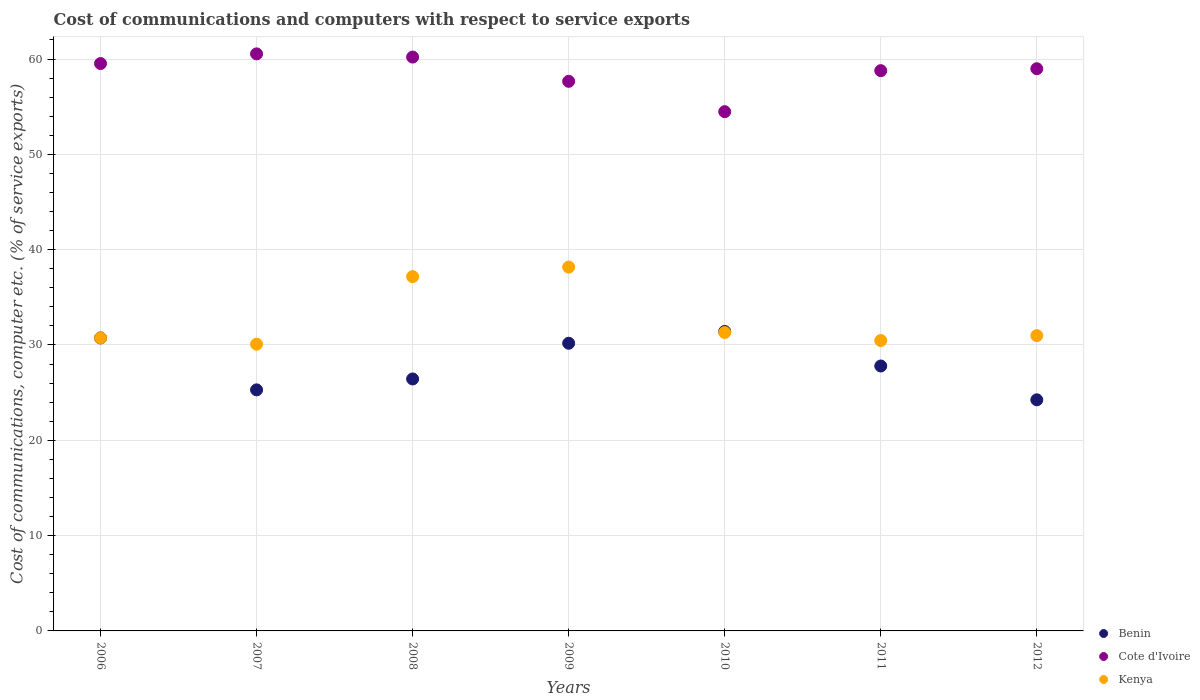Is the number of dotlines equal to the number of legend labels?
Keep it short and to the point. Yes. What is the cost of communications and computers in Benin in 2011?
Your answer should be very brief. 27.8. Across all years, what is the maximum cost of communications and computers in Kenya?
Make the answer very short. 38.17. Across all years, what is the minimum cost of communications and computers in Cote d'Ivoire?
Provide a short and direct response. 54.48. What is the total cost of communications and computers in Benin in the graph?
Your response must be concise. 196.11. What is the difference between the cost of communications and computers in Cote d'Ivoire in 2009 and that in 2010?
Provide a succinct answer. 3.18. What is the difference between the cost of communications and computers in Cote d'Ivoire in 2007 and the cost of communications and computers in Kenya in 2009?
Your response must be concise. 22.37. What is the average cost of communications and computers in Kenya per year?
Ensure brevity in your answer.  32.7. In the year 2006, what is the difference between the cost of communications and computers in Kenya and cost of communications and computers in Cote d'Ivoire?
Give a very brief answer. -28.78. In how many years, is the cost of communications and computers in Cote d'Ivoire greater than 2 %?
Make the answer very short. 7. What is the ratio of the cost of communications and computers in Cote d'Ivoire in 2007 to that in 2012?
Ensure brevity in your answer.  1.03. What is the difference between the highest and the second highest cost of communications and computers in Kenya?
Provide a succinct answer. 1. What is the difference between the highest and the lowest cost of communications and computers in Kenya?
Ensure brevity in your answer.  8.09. In how many years, is the cost of communications and computers in Kenya greater than the average cost of communications and computers in Kenya taken over all years?
Ensure brevity in your answer.  2. Is the cost of communications and computers in Benin strictly less than the cost of communications and computers in Kenya over the years?
Make the answer very short. No. What is the difference between two consecutive major ticks on the Y-axis?
Provide a succinct answer. 10. Are the values on the major ticks of Y-axis written in scientific E-notation?
Offer a terse response. No. Does the graph contain any zero values?
Your answer should be very brief. No. Does the graph contain grids?
Provide a succinct answer. Yes. Where does the legend appear in the graph?
Ensure brevity in your answer.  Bottom right. How are the legend labels stacked?
Keep it short and to the point. Vertical. What is the title of the graph?
Offer a very short reply. Cost of communications and computers with respect to service exports. What is the label or title of the X-axis?
Ensure brevity in your answer.  Years. What is the label or title of the Y-axis?
Provide a succinct answer. Cost of communications, computer etc. (% of service exports). What is the Cost of communications, computer etc. (% of service exports) of Benin in 2006?
Your answer should be very brief. 30.74. What is the Cost of communications, computer etc. (% of service exports) in Cote d'Ivoire in 2006?
Provide a short and direct response. 59.53. What is the Cost of communications, computer etc. (% of service exports) in Kenya in 2006?
Your answer should be compact. 30.74. What is the Cost of communications, computer etc. (% of service exports) of Benin in 2007?
Ensure brevity in your answer.  25.29. What is the Cost of communications, computer etc. (% of service exports) of Cote d'Ivoire in 2007?
Your answer should be very brief. 60.54. What is the Cost of communications, computer etc. (% of service exports) of Kenya in 2007?
Keep it short and to the point. 30.09. What is the Cost of communications, computer etc. (% of service exports) in Benin in 2008?
Your response must be concise. 26.43. What is the Cost of communications, computer etc. (% of service exports) of Cote d'Ivoire in 2008?
Offer a terse response. 60.21. What is the Cost of communications, computer etc. (% of service exports) in Kenya in 2008?
Give a very brief answer. 37.17. What is the Cost of communications, computer etc. (% of service exports) in Benin in 2009?
Give a very brief answer. 30.18. What is the Cost of communications, computer etc. (% of service exports) in Cote d'Ivoire in 2009?
Offer a very short reply. 57.66. What is the Cost of communications, computer etc. (% of service exports) of Kenya in 2009?
Ensure brevity in your answer.  38.17. What is the Cost of communications, computer etc. (% of service exports) of Benin in 2010?
Keep it short and to the point. 31.42. What is the Cost of communications, computer etc. (% of service exports) in Cote d'Ivoire in 2010?
Give a very brief answer. 54.48. What is the Cost of communications, computer etc. (% of service exports) in Kenya in 2010?
Provide a succinct answer. 31.31. What is the Cost of communications, computer etc. (% of service exports) in Benin in 2011?
Provide a succinct answer. 27.8. What is the Cost of communications, computer etc. (% of service exports) of Cote d'Ivoire in 2011?
Your answer should be compact. 58.78. What is the Cost of communications, computer etc. (% of service exports) of Kenya in 2011?
Ensure brevity in your answer.  30.47. What is the Cost of communications, computer etc. (% of service exports) of Benin in 2012?
Your answer should be compact. 24.25. What is the Cost of communications, computer etc. (% of service exports) in Cote d'Ivoire in 2012?
Make the answer very short. 58.99. What is the Cost of communications, computer etc. (% of service exports) in Kenya in 2012?
Your answer should be compact. 30.98. Across all years, what is the maximum Cost of communications, computer etc. (% of service exports) in Benin?
Ensure brevity in your answer.  31.42. Across all years, what is the maximum Cost of communications, computer etc. (% of service exports) in Cote d'Ivoire?
Give a very brief answer. 60.54. Across all years, what is the maximum Cost of communications, computer etc. (% of service exports) in Kenya?
Ensure brevity in your answer.  38.17. Across all years, what is the minimum Cost of communications, computer etc. (% of service exports) of Benin?
Provide a succinct answer. 24.25. Across all years, what is the minimum Cost of communications, computer etc. (% of service exports) in Cote d'Ivoire?
Keep it short and to the point. 54.48. Across all years, what is the minimum Cost of communications, computer etc. (% of service exports) in Kenya?
Offer a terse response. 30.09. What is the total Cost of communications, computer etc. (% of service exports) in Benin in the graph?
Make the answer very short. 196.11. What is the total Cost of communications, computer etc. (% of service exports) in Cote d'Ivoire in the graph?
Make the answer very short. 410.19. What is the total Cost of communications, computer etc. (% of service exports) in Kenya in the graph?
Provide a succinct answer. 228.93. What is the difference between the Cost of communications, computer etc. (% of service exports) of Benin in 2006 and that in 2007?
Your answer should be compact. 5.45. What is the difference between the Cost of communications, computer etc. (% of service exports) in Cote d'Ivoire in 2006 and that in 2007?
Your answer should be very brief. -1.02. What is the difference between the Cost of communications, computer etc. (% of service exports) of Kenya in 2006 and that in 2007?
Your response must be concise. 0.66. What is the difference between the Cost of communications, computer etc. (% of service exports) of Benin in 2006 and that in 2008?
Keep it short and to the point. 4.3. What is the difference between the Cost of communications, computer etc. (% of service exports) of Cote d'Ivoire in 2006 and that in 2008?
Give a very brief answer. -0.68. What is the difference between the Cost of communications, computer etc. (% of service exports) in Kenya in 2006 and that in 2008?
Make the answer very short. -6.43. What is the difference between the Cost of communications, computer etc. (% of service exports) in Benin in 2006 and that in 2009?
Give a very brief answer. 0.56. What is the difference between the Cost of communications, computer etc. (% of service exports) in Cote d'Ivoire in 2006 and that in 2009?
Your answer should be compact. 1.86. What is the difference between the Cost of communications, computer etc. (% of service exports) in Kenya in 2006 and that in 2009?
Your answer should be compact. -7.43. What is the difference between the Cost of communications, computer etc. (% of service exports) in Benin in 2006 and that in 2010?
Keep it short and to the point. -0.68. What is the difference between the Cost of communications, computer etc. (% of service exports) of Cote d'Ivoire in 2006 and that in 2010?
Your answer should be compact. 5.05. What is the difference between the Cost of communications, computer etc. (% of service exports) in Kenya in 2006 and that in 2010?
Give a very brief answer. -0.56. What is the difference between the Cost of communications, computer etc. (% of service exports) in Benin in 2006 and that in 2011?
Your answer should be compact. 2.94. What is the difference between the Cost of communications, computer etc. (% of service exports) of Cote d'Ivoire in 2006 and that in 2011?
Make the answer very short. 0.75. What is the difference between the Cost of communications, computer etc. (% of service exports) of Kenya in 2006 and that in 2011?
Your answer should be very brief. 0.28. What is the difference between the Cost of communications, computer etc. (% of service exports) of Benin in 2006 and that in 2012?
Give a very brief answer. 6.49. What is the difference between the Cost of communications, computer etc. (% of service exports) of Cote d'Ivoire in 2006 and that in 2012?
Keep it short and to the point. 0.54. What is the difference between the Cost of communications, computer etc. (% of service exports) of Kenya in 2006 and that in 2012?
Keep it short and to the point. -0.24. What is the difference between the Cost of communications, computer etc. (% of service exports) in Benin in 2007 and that in 2008?
Provide a succinct answer. -1.14. What is the difference between the Cost of communications, computer etc. (% of service exports) of Cote d'Ivoire in 2007 and that in 2008?
Your answer should be compact. 0.34. What is the difference between the Cost of communications, computer etc. (% of service exports) in Kenya in 2007 and that in 2008?
Provide a succinct answer. -7.08. What is the difference between the Cost of communications, computer etc. (% of service exports) of Benin in 2007 and that in 2009?
Give a very brief answer. -4.89. What is the difference between the Cost of communications, computer etc. (% of service exports) in Cote d'Ivoire in 2007 and that in 2009?
Give a very brief answer. 2.88. What is the difference between the Cost of communications, computer etc. (% of service exports) in Kenya in 2007 and that in 2009?
Offer a very short reply. -8.09. What is the difference between the Cost of communications, computer etc. (% of service exports) of Benin in 2007 and that in 2010?
Your answer should be very brief. -6.13. What is the difference between the Cost of communications, computer etc. (% of service exports) of Cote d'Ivoire in 2007 and that in 2010?
Provide a short and direct response. 6.07. What is the difference between the Cost of communications, computer etc. (% of service exports) in Kenya in 2007 and that in 2010?
Your answer should be very brief. -1.22. What is the difference between the Cost of communications, computer etc. (% of service exports) in Benin in 2007 and that in 2011?
Give a very brief answer. -2.5. What is the difference between the Cost of communications, computer etc. (% of service exports) of Cote d'Ivoire in 2007 and that in 2011?
Give a very brief answer. 1.76. What is the difference between the Cost of communications, computer etc. (% of service exports) of Kenya in 2007 and that in 2011?
Keep it short and to the point. -0.38. What is the difference between the Cost of communications, computer etc. (% of service exports) of Benin in 2007 and that in 2012?
Offer a very short reply. 1.04. What is the difference between the Cost of communications, computer etc. (% of service exports) in Cote d'Ivoire in 2007 and that in 2012?
Make the answer very short. 1.56. What is the difference between the Cost of communications, computer etc. (% of service exports) in Kenya in 2007 and that in 2012?
Offer a terse response. -0.9. What is the difference between the Cost of communications, computer etc. (% of service exports) of Benin in 2008 and that in 2009?
Your answer should be compact. -3.75. What is the difference between the Cost of communications, computer etc. (% of service exports) in Cote d'Ivoire in 2008 and that in 2009?
Offer a terse response. 2.54. What is the difference between the Cost of communications, computer etc. (% of service exports) in Kenya in 2008 and that in 2009?
Keep it short and to the point. -1. What is the difference between the Cost of communications, computer etc. (% of service exports) in Benin in 2008 and that in 2010?
Ensure brevity in your answer.  -4.99. What is the difference between the Cost of communications, computer etc. (% of service exports) of Cote d'Ivoire in 2008 and that in 2010?
Make the answer very short. 5.73. What is the difference between the Cost of communications, computer etc. (% of service exports) in Kenya in 2008 and that in 2010?
Your response must be concise. 5.86. What is the difference between the Cost of communications, computer etc. (% of service exports) in Benin in 2008 and that in 2011?
Provide a succinct answer. -1.36. What is the difference between the Cost of communications, computer etc. (% of service exports) in Cote d'Ivoire in 2008 and that in 2011?
Offer a terse response. 1.43. What is the difference between the Cost of communications, computer etc. (% of service exports) of Kenya in 2008 and that in 2011?
Make the answer very short. 6.7. What is the difference between the Cost of communications, computer etc. (% of service exports) of Benin in 2008 and that in 2012?
Offer a very short reply. 2.19. What is the difference between the Cost of communications, computer etc. (% of service exports) in Cote d'Ivoire in 2008 and that in 2012?
Provide a succinct answer. 1.22. What is the difference between the Cost of communications, computer etc. (% of service exports) of Kenya in 2008 and that in 2012?
Your answer should be very brief. 6.19. What is the difference between the Cost of communications, computer etc. (% of service exports) in Benin in 2009 and that in 2010?
Your answer should be very brief. -1.24. What is the difference between the Cost of communications, computer etc. (% of service exports) in Cote d'Ivoire in 2009 and that in 2010?
Keep it short and to the point. 3.19. What is the difference between the Cost of communications, computer etc. (% of service exports) of Kenya in 2009 and that in 2010?
Make the answer very short. 6.87. What is the difference between the Cost of communications, computer etc. (% of service exports) in Benin in 2009 and that in 2011?
Keep it short and to the point. 2.39. What is the difference between the Cost of communications, computer etc. (% of service exports) of Cote d'Ivoire in 2009 and that in 2011?
Offer a terse response. -1.12. What is the difference between the Cost of communications, computer etc. (% of service exports) in Kenya in 2009 and that in 2011?
Your answer should be compact. 7.71. What is the difference between the Cost of communications, computer etc. (% of service exports) in Benin in 2009 and that in 2012?
Make the answer very short. 5.93. What is the difference between the Cost of communications, computer etc. (% of service exports) of Cote d'Ivoire in 2009 and that in 2012?
Offer a very short reply. -1.32. What is the difference between the Cost of communications, computer etc. (% of service exports) in Kenya in 2009 and that in 2012?
Provide a succinct answer. 7.19. What is the difference between the Cost of communications, computer etc. (% of service exports) in Benin in 2010 and that in 2011?
Provide a succinct answer. 3.63. What is the difference between the Cost of communications, computer etc. (% of service exports) in Cote d'Ivoire in 2010 and that in 2011?
Your answer should be very brief. -4.3. What is the difference between the Cost of communications, computer etc. (% of service exports) in Kenya in 2010 and that in 2011?
Ensure brevity in your answer.  0.84. What is the difference between the Cost of communications, computer etc. (% of service exports) in Benin in 2010 and that in 2012?
Ensure brevity in your answer.  7.17. What is the difference between the Cost of communications, computer etc. (% of service exports) of Cote d'Ivoire in 2010 and that in 2012?
Ensure brevity in your answer.  -4.51. What is the difference between the Cost of communications, computer etc. (% of service exports) of Kenya in 2010 and that in 2012?
Provide a short and direct response. 0.33. What is the difference between the Cost of communications, computer etc. (% of service exports) in Benin in 2011 and that in 2012?
Your answer should be compact. 3.55. What is the difference between the Cost of communications, computer etc. (% of service exports) of Cote d'Ivoire in 2011 and that in 2012?
Provide a short and direct response. -0.2. What is the difference between the Cost of communications, computer etc. (% of service exports) in Kenya in 2011 and that in 2012?
Keep it short and to the point. -0.52. What is the difference between the Cost of communications, computer etc. (% of service exports) of Benin in 2006 and the Cost of communications, computer etc. (% of service exports) of Cote d'Ivoire in 2007?
Offer a very short reply. -29.8. What is the difference between the Cost of communications, computer etc. (% of service exports) of Benin in 2006 and the Cost of communications, computer etc. (% of service exports) of Kenya in 2007?
Provide a short and direct response. 0.65. What is the difference between the Cost of communications, computer etc. (% of service exports) of Cote d'Ivoire in 2006 and the Cost of communications, computer etc. (% of service exports) of Kenya in 2007?
Your answer should be very brief. 29.44. What is the difference between the Cost of communications, computer etc. (% of service exports) in Benin in 2006 and the Cost of communications, computer etc. (% of service exports) in Cote d'Ivoire in 2008?
Ensure brevity in your answer.  -29.47. What is the difference between the Cost of communications, computer etc. (% of service exports) of Benin in 2006 and the Cost of communications, computer etc. (% of service exports) of Kenya in 2008?
Provide a succinct answer. -6.43. What is the difference between the Cost of communications, computer etc. (% of service exports) of Cote d'Ivoire in 2006 and the Cost of communications, computer etc. (% of service exports) of Kenya in 2008?
Provide a succinct answer. 22.36. What is the difference between the Cost of communications, computer etc. (% of service exports) of Benin in 2006 and the Cost of communications, computer etc. (% of service exports) of Cote d'Ivoire in 2009?
Offer a very short reply. -26.92. What is the difference between the Cost of communications, computer etc. (% of service exports) of Benin in 2006 and the Cost of communications, computer etc. (% of service exports) of Kenya in 2009?
Provide a succinct answer. -7.43. What is the difference between the Cost of communications, computer etc. (% of service exports) in Cote d'Ivoire in 2006 and the Cost of communications, computer etc. (% of service exports) in Kenya in 2009?
Provide a succinct answer. 21.35. What is the difference between the Cost of communications, computer etc. (% of service exports) in Benin in 2006 and the Cost of communications, computer etc. (% of service exports) in Cote d'Ivoire in 2010?
Offer a terse response. -23.74. What is the difference between the Cost of communications, computer etc. (% of service exports) in Benin in 2006 and the Cost of communications, computer etc. (% of service exports) in Kenya in 2010?
Offer a very short reply. -0.57. What is the difference between the Cost of communications, computer etc. (% of service exports) of Cote d'Ivoire in 2006 and the Cost of communications, computer etc. (% of service exports) of Kenya in 2010?
Your answer should be very brief. 28.22. What is the difference between the Cost of communications, computer etc. (% of service exports) in Benin in 2006 and the Cost of communications, computer etc. (% of service exports) in Cote d'Ivoire in 2011?
Ensure brevity in your answer.  -28.04. What is the difference between the Cost of communications, computer etc. (% of service exports) of Benin in 2006 and the Cost of communications, computer etc. (% of service exports) of Kenya in 2011?
Offer a very short reply. 0.27. What is the difference between the Cost of communications, computer etc. (% of service exports) of Cote d'Ivoire in 2006 and the Cost of communications, computer etc. (% of service exports) of Kenya in 2011?
Your response must be concise. 29.06. What is the difference between the Cost of communications, computer etc. (% of service exports) in Benin in 2006 and the Cost of communications, computer etc. (% of service exports) in Cote d'Ivoire in 2012?
Offer a terse response. -28.25. What is the difference between the Cost of communications, computer etc. (% of service exports) of Benin in 2006 and the Cost of communications, computer etc. (% of service exports) of Kenya in 2012?
Offer a very short reply. -0.24. What is the difference between the Cost of communications, computer etc. (% of service exports) in Cote d'Ivoire in 2006 and the Cost of communications, computer etc. (% of service exports) in Kenya in 2012?
Give a very brief answer. 28.55. What is the difference between the Cost of communications, computer etc. (% of service exports) of Benin in 2007 and the Cost of communications, computer etc. (% of service exports) of Cote d'Ivoire in 2008?
Offer a very short reply. -34.92. What is the difference between the Cost of communications, computer etc. (% of service exports) in Benin in 2007 and the Cost of communications, computer etc. (% of service exports) in Kenya in 2008?
Offer a very short reply. -11.88. What is the difference between the Cost of communications, computer etc. (% of service exports) of Cote d'Ivoire in 2007 and the Cost of communications, computer etc. (% of service exports) of Kenya in 2008?
Provide a succinct answer. 23.37. What is the difference between the Cost of communications, computer etc. (% of service exports) of Benin in 2007 and the Cost of communications, computer etc. (% of service exports) of Cote d'Ivoire in 2009?
Offer a very short reply. -32.37. What is the difference between the Cost of communications, computer etc. (% of service exports) of Benin in 2007 and the Cost of communications, computer etc. (% of service exports) of Kenya in 2009?
Provide a short and direct response. -12.88. What is the difference between the Cost of communications, computer etc. (% of service exports) in Cote d'Ivoire in 2007 and the Cost of communications, computer etc. (% of service exports) in Kenya in 2009?
Provide a short and direct response. 22.37. What is the difference between the Cost of communications, computer etc. (% of service exports) in Benin in 2007 and the Cost of communications, computer etc. (% of service exports) in Cote d'Ivoire in 2010?
Make the answer very short. -29.19. What is the difference between the Cost of communications, computer etc. (% of service exports) in Benin in 2007 and the Cost of communications, computer etc. (% of service exports) in Kenya in 2010?
Your response must be concise. -6.02. What is the difference between the Cost of communications, computer etc. (% of service exports) in Cote d'Ivoire in 2007 and the Cost of communications, computer etc. (% of service exports) in Kenya in 2010?
Give a very brief answer. 29.24. What is the difference between the Cost of communications, computer etc. (% of service exports) of Benin in 2007 and the Cost of communications, computer etc. (% of service exports) of Cote d'Ivoire in 2011?
Provide a succinct answer. -33.49. What is the difference between the Cost of communications, computer etc. (% of service exports) of Benin in 2007 and the Cost of communications, computer etc. (% of service exports) of Kenya in 2011?
Give a very brief answer. -5.18. What is the difference between the Cost of communications, computer etc. (% of service exports) of Cote d'Ivoire in 2007 and the Cost of communications, computer etc. (% of service exports) of Kenya in 2011?
Provide a succinct answer. 30.08. What is the difference between the Cost of communications, computer etc. (% of service exports) of Benin in 2007 and the Cost of communications, computer etc. (% of service exports) of Cote d'Ivoire in 2012?
Offer a very short reply. -33.7. What is the difference between the Cost of communications, computer etc. (% of service exports) of Benin in 2007 and the Cost of communications, computer etc. (% of service exports) of Kenya in 2012?
Your answer should be compact. -5.69. What is the difference between the Cost of communications, computer etc. (% of service exports) of Cote d'Ivoire in 2007 and the Cost of communications, computer etc. (% of service exports) of Kenya in 2012?
Make the answer very short. 29.56. What is the difference between the Cost of communications, computer etc. (% of service exports) of Benin in 2008 and the Cost of communications, computer etc. (% of service exports) of Cote d'Ivoire in 2009?
Keep it short and to the point. -31.23. What is the difference between the Cost of communications, computer etc. (% of service exports) in Benin in 2008 and the Cost of communications, computer etc. (% of service exports) in Kenya in 2009?
Provide a succinct answer. -11.74. What is the difference between the Cost of communications, computer etc. (% of service exports) of Cote d'Ivoire in 2008 and the Cost of communications, computer etc. (% of service exports) of Kenya in 2009?
Provide a short and direct response. 22.03. What is the difference between the Cost of communications, computer etc. (% of service exports) in Benin in 2008 and the Cost of communications, computer etc. (% of service exports) in Cote d'Ivoire in 2010?
Give a very brief answer. -28.04. What is the difference between the Cost of communications, computer etc. (% of service exports) of Benin in 2008 and the Cost of communications, computer etc. (% of service exports) of Kenya in 2010?
Provide a succinct answer. -4.87. What is the difference between the Cost of communications, computer etc. (% of service exports) in Cote d'Ivoire in 2008 and the Cost of communications, computer etc. (% of service exports) in Kenya in 2010?
Your response must be concise. 28.9. What is the difference between the Cost of communications, computer etc. (% of service exports) of Benin in 2008 and the Cost of communications, computer etc. (% of service exports) of Cote d'Ivoire in 2011?
Your answer should be very brief. -32.35. What is the difference between the Cost of communications, computer etc. (% of service exports) in Benin in 2008 and the Cost of communications, computer etc. (% of service exports) in Kenya in 2011?
Give a very brief answer. -4.03. What is the difference between the Cost of communications, computer etc. (% of service exports) of Cote d'Ivoire in 2008 and the Cost of communications, computer etc. (% of service exports) of Kenya in 2011?
Offer a terse response. 29.74. What is the difference between the Cost of communications, computer etc. (% of service exports) in Benin in 2008 and the Cost of communications, computer etc. (% of service exports) in Cote d'Ivoire in 2012?
Your response must be concise. -32.55. What is the difference between the Cost of communications, computer etc. (% of service exports) in Benin in 2008 and the Cost of communications, computer etc. (% of service exports) in Kenya in 2012?
Keep it short and to the point. -4.55. What is the difference between the Cost of communications, computer etc. (% of service exports) of Cote d'Ivoire in 2008 and the Cost of communications, computer etc. (% of service exports) of Kenya in 2012?
Give a very brief answer. 29.23. What is the difference between the Cost of communications, computer etc. (% of service exports) in Benin in 2009 and the Cost of communications, computer etc. (% of service exports) in Cote d'Ivoire in 2010?
Provide a short and direct response. -24.3. What is the difference between the Cost of communications, computer etc. (% of service exports) of Benin in 2009 and the Cost of communications, computer etc. (% of service exports) of Kenya in 2010?
Provide a succinct answer. -1.13. What is the difference between the Cost of communications, computer etc. (% of service exports) of Cote d'Ivoire in 2009 and the Cost of communications, computer etc. (% of service exports) of Kenya in 2010?
Make the answer very short. 26.36. What is the difference between the Cost of communications, computer etc. (% of service exports) of Benin in 2009 and the Cost of communications, computer etc. (% of service exports) of Cote d'Ivoire in 2011?
Provide a succinct answer. -28.6. What is the difference between the Cost of communications, computer etc. (% of service exports) of Benin in 2009 and the Cost of communications, computer etc. (% of service exports) of Kenya in 2011?
Your answer should be very brief. -0.28. What is the difference between the Cost of communications, computer etc. (% of service exports) in Cote d'Ivoire in 2009 and the Cost of communications, computer etc. (% of service exports) in Kenya in 2011?
Your response must be concise. 27.2. What is the difference between the Cost of communications, computer etc. (% of service exports) in Benin in 2009 and the Cost of communications, computer etc. (% of service exports) in Cote d'Ivoire in 2012?
Give a very brief answer. -28.8. What is the difference between the Cost of communications, computer etc. (% of service exports) of Benin in 2009 and the Cost of communications, computer etc. (% of service exports) of Kenya in 2012?
Your answer should be very brief. -0.8. What is the difference between the Cost of communications, computer etc. (% of service exports) of Cote d'Ivoire in 2009 and the Cost of communications, computer etc. (% of service exports) of Kenya in 2012?
Offer a very short reply. 26.68. What is the difference between the Cost of communications, computer etc. (% of service exports) in Benin in 2010 and the Cost of communications, computer etc. (% of service exports) in Cote d'Ivoire in 2011?
Keep it short and to the point. -27.36. What is the difference between the Cost of communications, computer etc. (% of service exports) of Benin in 2010 and the Cost of communications, computer etc. (% of service exports) of Kenya in 2011?
Ensure brevity in your answer.  0.95. What is the difference between the Cost of communications, computer etc. (% of service exports) of Cote d'Ivoire in 2010 and the Cost of communications, computer etc. (% of service exports) of Kenya in 2011?
Offer a terse response. 24.01. What is the difference between the Cost of communications, computer etc. (% of service exports) in Benin in 2010 and the Cost of communications, computer etc. (% of service exports) in Cote d'Ivoire in 2012?
Ensure brevity in your answer.  -27.57. What is the difference between the Cost of communications, computer etc. (% of service exports) in Benin in 2010 and the Cost of communications, computer etc. (% of service exports) in Kenya in 2012?
Ensure brevity in your answer.  0.44. What is the difference between the Cost of communications, computer etc. (% of service exports) of Cote d'Ivoire in 2010 and the Cost of communications, computer etc. (% of service exports) of Kenya in 2012?
Provide a succinct answer. 23.5. What is the difference between the Cost of communications, computer etc. (% of service exports) in Benin in 2011 and the Cost of communications, computer etc. (% of service exports) in Cote d'Ivoire in 2012?
Your answer should be very brief. -31.19. What is the difference between the Cost of communications, computer etc. (% of service exports) in Benin in 2011 and the Cost of communications, computer etc. (% of service exports) in Kenya in 2012?
Provide a succinct answer. -3.19. What is the difference between the Cost of communications, computer etc. (% of service exports) of Cote d'Ivoire in 2011 and the Cost of communications, computer etc. (% of service exports) of Kenya in 2012?
Your answer should be very brief. 27.8. What is the average Cost of communications, computer etc. (% of service exports) of Benin per year?
Offer a terse response. 28.02. What is the average Cost of communications, computer etc. (% of service exports) of Cote d'Ivoire per year?
Ensure brevity in your answer.  58.6. What is the average Cost of communications, computer etc. (% of service exports) of Kenya per year?
Offer a terse response. 32.7. In the year 2006, what is the difference between the Cost of communications, computer etc. (% of service exports) in Benin and Cost of communications, computer etc. (% of service exports) in Cote d'Ivoire?
Your answer should be very brief. -28.79. In the year 2006, what is the difference between the Cost of communications, computer etc. (% of service exports) in Benin and Cost of communications, computer etc. (% of service exports) in Kenya?
Give a very brief answer. -0. In the year 2006, what is the difference between the Cost of communications, computer etc. (% of service exports) of Cote d'Ivoire and Cost of communications, computer etc. (% of service exports) of Kenya?
Offer a very short reply. 28.78. In the year 2007, what is the difference between the Cost of communications, computer etc. (% of service exports) of Benin and Cost of communications, computer etc. (% of service exports) of Cote d'Ivoire?
Ensure brevity in your answer.  -35.25. In the year 2007, what is the difference between the Cost of communications, computer etc. (% of service exports) of Benin and Cost of communications, computer etc. (% of service exports) of Kenya?
Offer a very short reply. -4.8. In the year 2007, what is the difference between the Cost of communications, computer etc. (% of service exports) of Cote d'Ivoire and Cost of communications, computer etc. (% of service exports) of Kenya?
Ensure brevity in your answer.  30.46. In the year 2008, what is the difference between the Cost of communications, computer etc. (% of service exports) of Benin and Cost of communications, computer etc. (% of service exports) of Cote d'Ivoire?
Make the answer very short. -33.77. In the year 2008, what is the difference between the Cost of communications, computer etc. (% of service exports) of Benin and Cost of communications, computer etc. (% of service exports) of Kenya?
Provide a short and direct response. -10.73. In the year 2008, what is the difference between the Cost of communications, computer etc. (% of service exports) of Cote d'Ivoire and Cost of communications, computer etc. (% of service exports) of Kenya?
Keep it short and to the point. 23.04. In the year 2009, what is the difference between the Cost of communications, computer etc. (% of service exports) of Benin and Cost of communications, computer etc. (% of service exports) of Cote d'Ivoire?
Provide a succinct answer. -27.48. In the year 2009, what is the difference between the Cost of communications, computer etc. (% of service exports) of Benin and Cost of communications, computer etc. (% of service exports) of Kenya?
Give a very brief answer. -7.99. In the year 2009, what is the difference between the Cost of communications, computer etc. (% of service exports) in Cote d'Ivoire and Cost of communications, computer etc. (% of service exports) in Kenya?
Your answer should be very brief. 19.49. In the year 2010, what is the difference between the Cost of communications, computer etc. (% of service exports) of Benin and Cost of communications, computer etc. (% of service exports) of Cote d'Ivoire?
Make the answer very short. -23.06. In the year 2010, what is the difference between the Cost of communications, computer etc. (% of service exports) in Benin and Cost of communications, computer etc. (% of service exports) in Kenya?
Your response must be concise. 0.11. In the year 2010, what is the difference between the Cost of communications, computer etc. (% of service exports) of Cote d'Ivoire and Cost of communications, computer etc. (% of service exports) of Kenya?
Give a very brief answer. 23.17. In the year 2011, what is the difference between the Cost of communications, computer etc. (% of service exports) of Benin and Cost of communications, computer etc. (% of service exports) of Cote d'Ivoire?
Your answer should be very brief. -30.99. In the year 2011, what is the difference between the Cost of communications, computer etc. (% of service exports) of Benin and Cost of communications, computer etc. (% of service exports) of Kenya?
Ensure brevity in your answer.  -2.67. In the year 2011, what is the difference between the Cost of communications, computer etc. (% of service exports) of Cote d'Ivoire and Cost of communications, computer etc. (% of service exports) of Kenya?
Your answer should be compact. 28.32. In the year 2012, what is the difference between the Cost of communications, computer etc. (% of service exports) in Benin and Cost of communications, computer etc. (% of service exports) in Cote d'Ivoire?
Your answer should be very brief. -34.74. In the year 2012, what is the difference between the Cost of communications, computer etc. (% of service exports) in Benin and Cost of communications, computer etc. (% of service exports) in Kenya?
Give a very brief answer. -6.73. In the year 2012, what is the difference between the Cost of communications, computer etc. (% of service exports) in Cote d'Ivoire and Cost of communications, computer etc. (% of service exports) in Kenya?
Offer a terse response. 28. What is the ratio of the Cost of communications, computer etc. (% of service exports) in Benin in 2006 to that in 2007?
Your response must be concise. 1.22. What is the ratio of the Cost of communications, computer etc. (% of service exports) in Cote d'Ivoire in 2006 to that in 2007?
Offer a terse response. 0.98. What is the ratio of the Cost of communications, computer etc. (% of service exports) of Kenya in 2006 to that in 2007?
Provide a succinct answer. 1.02. What is the ratio of the Cost of communications, computer etc. (% of service exports) in Benin in 2006 to that in 2008?
Provide a short and direct response. 1.16. What is the ratio of the Cost of communications, computer etc. (% of service exports) in Cote d'Ivoire in 2006 to that in 2008?
Keep it short and to the point. 0.99. What is the ratio of the Cost of communications, computer etc. (% of service exports) of Kenya in 2006 to that in 2008?
Ensure brevity in your answer.  0.83. What is the ratio of the Cost of communications, computer etc. (% of service exports) of Benin in 2006 to that in 2009?
Provide a succinct answer. 1.02. What is the ratio of the Cost of communications, computer etc. (% of service exports) of Cote d'Ivoire in 2006 to that in 2009?
Your answer should be compact. 1.03. What is the ratio of the Cost of communications, computer etc. (% of service exports) in Kenya in 2006 to that in 2009?
Offer a very short reply. 0.81. What is the ratio of the Cost of communications, computer etc. (% of service exports) in Benin in 2006 to that in 2010?
Provide a succinct answer. 0.98. What is the ratio of the Cost of communications, computer etc. (% of service exports) of Cote d'Ivoire in 2006 to that in 2010?
Offer a very short reply. 1.09. What is the ratio of the Cost of communications, computer etc. (% of service exports) of Benin in 2006 to that in 2011?
Provide a succinct answer. 1.11. What is the ratio of the Cost of communications, computer etc. (% of service exports) of Cote d'Ivoire in 2006 to that in 2011?
Offer a very short reply. 1.01. What is the ratio of the Cost of communications, computer etc. (% of service exports) of Kenya in 2006 to that in 2011?
Your answer should be compact. 1.01. What is the ratio of the Cost of communications, computer etc. (% of service exports) of Benin in 2006 to that in 2012?
Offer a very short reply. 1.27. What is the ratio of the Cost of communications, computer etc. (% of service exports) in Cote d'Ivoire in 2006 to that in 2012?
Ensure brevity in your answer.  1.01. What is the ratio of the Cost of communications, computer etc. (% of service exports) of Kenya in 2006 to that in 2012?
Offer a very short reply. 0.99. What is the ratio of the Cost of communications, computer etc. (% of service exports) in Benin in 2007 to that in 2008?
Your answer should be very brief. 0.96. What is the ratio of the Cost of communications, computer etc. (% of service exports) in Cote d'Ivoire in 2007 to that in 2008?
Offer a very short reply. 1.01. What is the ratio of the Cost of communications, computer etc. (% of service exports) of Kenya in 2007 to that in 2008?
Make the answer very short. 0.81. What is the ratio of the Cost of communications, computer etc. (% of service exports) in Benin in 2007 to that in 2009?
Your answer should be very brief. 0.84. What is the ratio of the Cost of communications, computer etc. (% of service exports) in Cote d'Ivoire in 2007 to that in 2009?
Ensure brevity in your answer.  1.05. What is the ratio of the Cost of communications, computer etc. (% of service exports) of Kenya in 2007 to that in 2009?
Provide a succinct answer. 0.79. What is the ratio of the Cost of communications, computer etc. (% of service exports) of Benin in 2007 to that in 2010?
Provide a short and direct response. 0.8. What is the ratio of the Cost of communications, computer etc. (% of service exports) in Cote d'Ivoire in 2007 to that in 2010?
Provide a succinct answer. 1.11. What is the ratio of the Cost of communications, computer etc. (% of service exports) in Benin in 2007 to that in 2011?
Your answer should be very brief. 0.91. What is the ratio of the Cost of communications, computer etc. (% of service exports) in Cote d'Ivoire in 2007 to that in 2011?
Provide a succinct answer. 1.03. What is the ratio of the Cost of communications, computer etc. (% of service exports) in Kenya in 2007 to that in 2011?
Your answer should be very brief. 0.99. What is the ratio of the Cost of communications, computer etc. (% of service exports) of Benin in 2007 to that in 2012?
Keep it short and to the point. 1.04. What is the ratio of the Cost of communications, computer etc. (% of service exports) in Cote d'Ivoire in 2007 to that in 2012?
Keep it short and to the point. 1.03. What is the ratio of the Cost of communications, computer etc. (% of service exports) in Kenya in 2007 to that in 2012?
Keep it short and to the point. 0.97. What is the ratio of the Cost of communications, computer etc. (% of service exports) of Benin in 2008 to that in 2009?
Your answer should be compact. 0.88. What is the ratio of the Cost of communications, computer etc. (% of service exports) of Cote d'Ivoire in 2008 to that in 2009?
Your answer should be compact. 1.04. What is the ratio of the Cost of communications, computer etc. (% of service exports) of Kenya in 2008 to that in 2009?
Keep it short and to the point. 0.97. What is the ratio of the Cost of communications, computer etc. (% of service exports) in Benin in 2008 to that in 2010?
Give a very brief answer. 0.84. What is the ratio of the Cost of communications, computer etc. (% of service exports) in Cote d'Ivoire in 2008 to that in 2010?
Ensure brevity in your answer.  1.11. What is the ratio of the Cost of communications, computer etc. (% of service exports) of Kenya in 2008 to that in 2010?
Your answer should be very brief. 1.19. What is the ratio of the Cost of communications, computer etc. (% of service exports) of Benin in 2008 to that in 2011?
Your answer should be compact. 0.95. What is the ratio of the Cost of communications, computer etc. (% of service exports) of Cote d'Ivoire in 2008 to that in 2011?
Your answer should be compact. 1.02. What is the ratio of the Cost of communications, computer etc. (% of service exports) in Kenya in 2008 to that in 2011?
Your response must be concise. 1.22. What is the ratio of the Cost of communications, computer etc. (% of service exports) in Benin in 2008 to that in 2012?
Offer a very short reply. 1.09. What is the ratio of the Cost of communications, computer etc. (% of service exports) in Cote d'Ivoire in 2008 to that in 2012?
Keep it short and to the point. 1.02. What is the ratio of the Cost of communications, computer etc. (% of service exports) of Kenya in 2008 to that in 2012?
Your answer should be compact. 1.2. What is the ratio of the Cost of communications, computer etc. (% of service exports) in Benin in 2009 to that in 2010?
Offer a terse response. 0.96. What is the ratio of the Cost of communications, computer etc. (% of service exports) of Cote d'Ivoire in 2009 to that in 2010?
Offer a very short reply. 1.06. What is the ratio of the Cost of communications, computer etc. (% of service exports) in Kenya in 2009 to that in 2010?
Provide a succinct answer. 1.22. What is the ratio of the Cost of communications, computer etc. (% of service exports) of Benin in 2009 to that in 2011?
Provide a succinct answer. 1.09. What is the ratio of the Cost of communications, computer etc. (% of service exports) in Cote d'Ivoire in 2009 to that in 2011?
Make the answer very short. 0.98. What is the ratio of the Cost of communications, computer etc. (% of service exports) in Kenya in 2009 to that in 2011?
Ensure brevity in your answer.  1.25. What is the ratio of the Cost of communications, computer etc. (% of service exports) of Benin in 2009 to that in 2012?
Provide a succinct answer. 1.24. What is the ratio of the Cost of communications, computer etc. (% of service exports) in Cote d'Ivoire in 2009 to that in 2012?
Keep it short and to the point. 0.98. What is the ratio of the Cost of communications, computer etc. (% of service exports) of Kenya in 2009 to that in 2012?
Make the answer very short. 1.23. What is the ratio of the Cost of communications, computer etc. (% of service exports) in Benin in 2010 to that in 2011?
Offer a very short reply. 1.13. What is the ratio of the Cost of communications, computer etc. (% of service exports) of Cote d'Ivoire in 2010 to that in 2011?
Make the answer very short. 0.93. What is the ratio of the Cost of communications, computer etc. (% of service exports) in Kenya in 2010 to that in 2011?
Provide a succinct answer. 1.03. What is the ratio of the Cost of communications, computer etc. (% of service exports) in Benin in 2010 to that in 2012?
Your answer should be very brief. 1.3. What is the ratio of the Cost of communications, computer etc. (% of service exports) of Cote d'Ivoire in 2010 to that in 2012?
Offer a terse response. 0.92. What is the ratio of the Cost of communications, computer etc. (% of service exports) of Kenya in 2010 to that in 2012?
Give a very brief answer. 1.01. What is the ratio of the Cost of communications, computer etc. (% of service exports) of Benin in 2011 to that in 2012?
Offer a very short reply. 1.15. What is the ratio of the Cost of communications, computer etc. (% of service exports) of Kenya in 2011 to that in 2012?
Offer a very short reply. 0.98. What is the difference between the highest and the second highest Cost of communications, computer etc. (% of service exports) in Benin?
Provide a short and direct response. 0.68. What is the difference between the highest and the second highest Cost of communications, computer etc. (% of service exports) in Cote d'Ivoire?
Keep it short and to the point. 0.34. What is the difference between the highest and the lowest Cost of communications, computer etc. (% of service exports) of Benin?
Offer a terse response. 7.17. What is the difference between the highest and the lowest Cost of communications, computer etc. (% of service exports) in Cote d'Ivoire?
Your answer should be compact. 6.07. What is the difference between the highest and the lowest Cost of communications, computer etc. (% of service exports) of Kenya?
Provide a short and direct response. 8.09. 